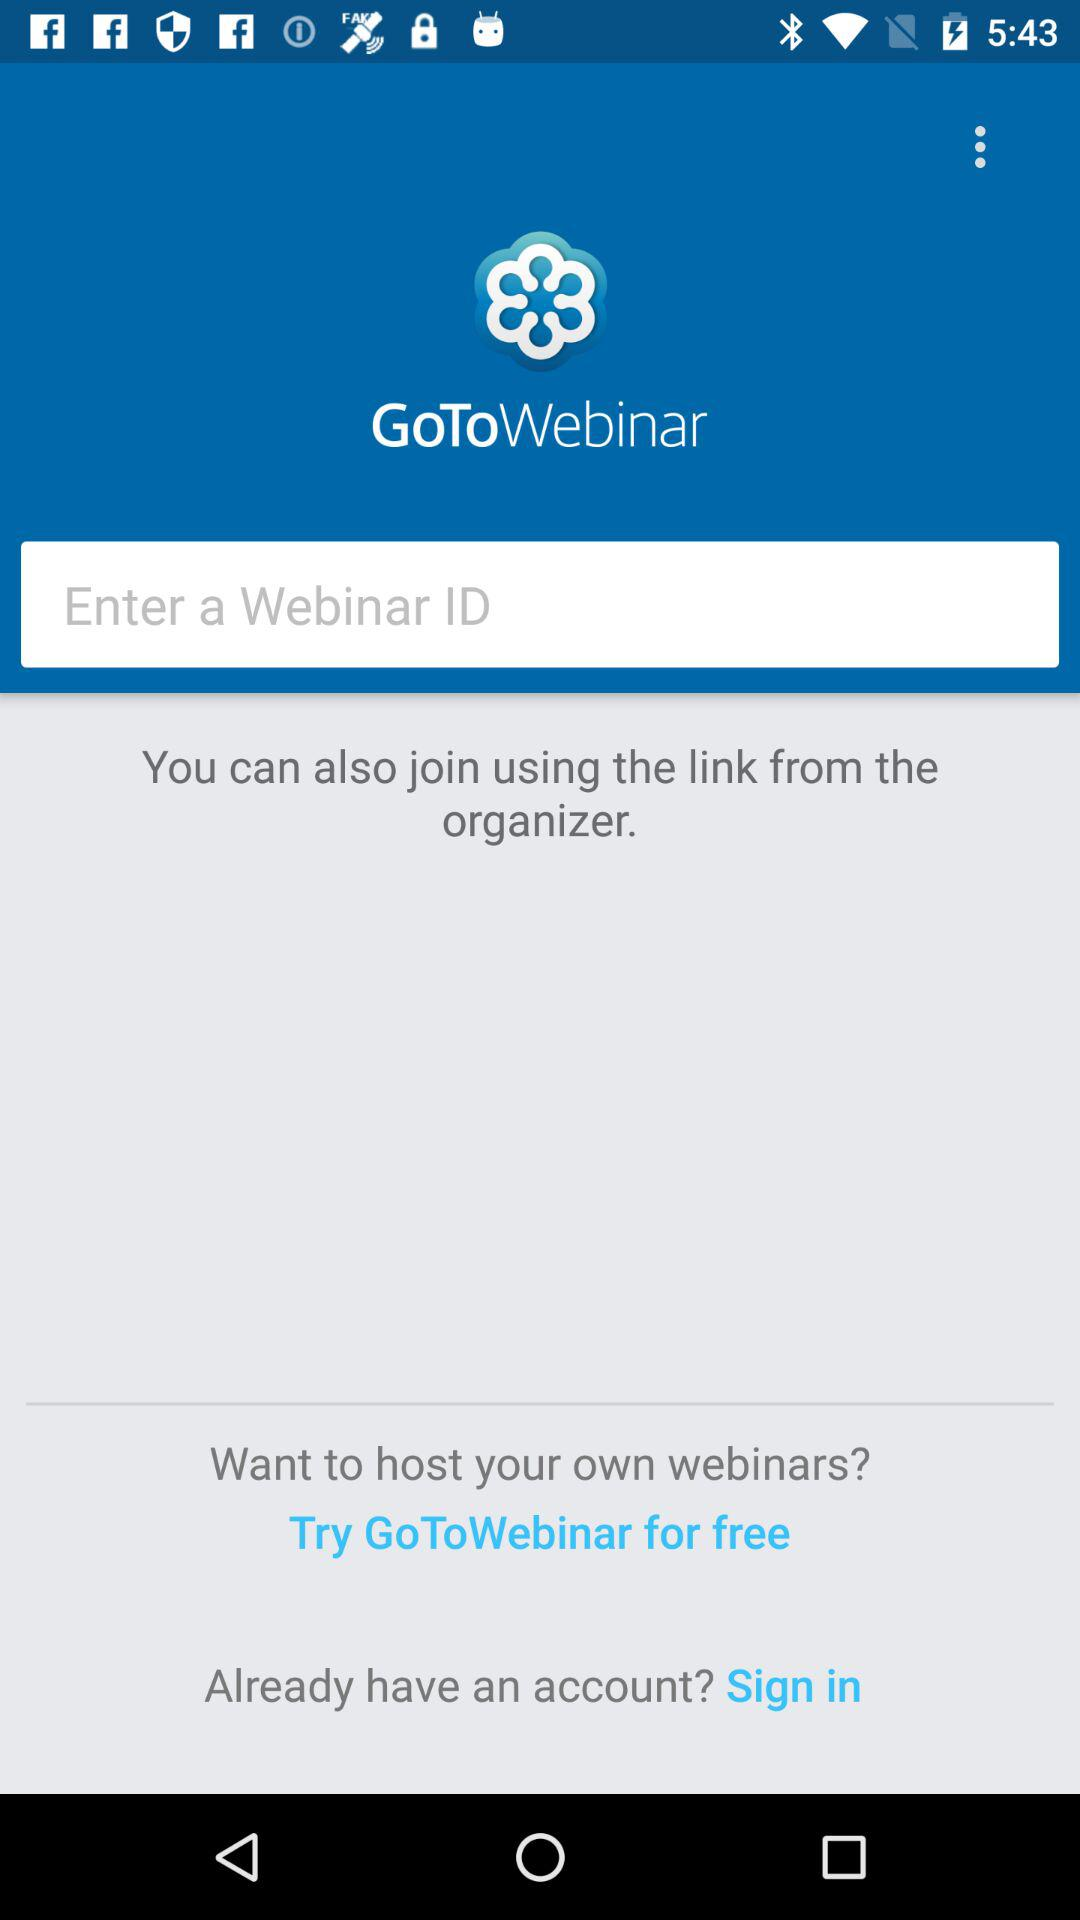What is the application name? The application name is "GoToWebinar". 